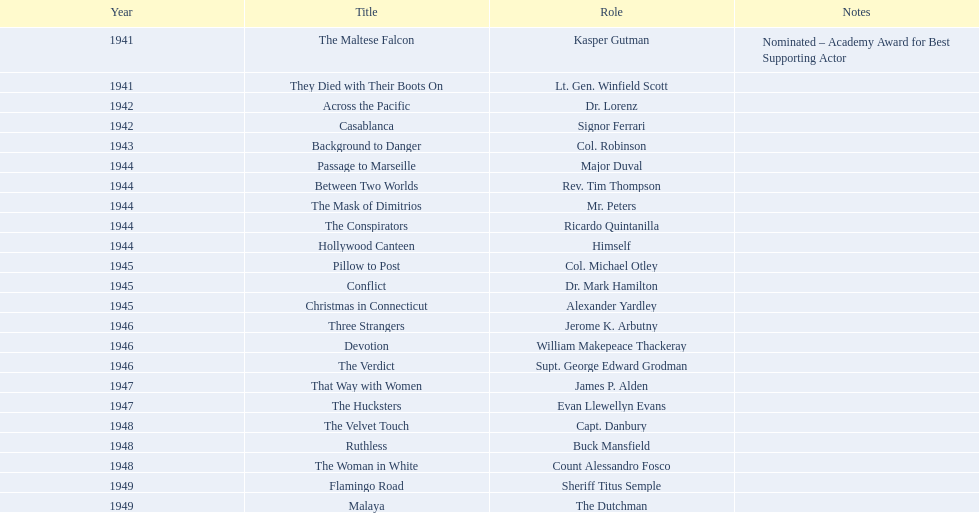What are the mentioned films? The Maltese Falcon, They Died with Their Boots On, Across the Pacific, Casablanca, Background to Danger, Passage to Marseille, Between Two Worlds, The Mask of Dimitrios, The Conspirators, Hollywood Canteen, Pillow to Post, Conflict, Christmas in Connecticut, Three Strangers, Devotion, The Verdict, That Way with Women, The Hucksters, The Velvet Touch, Ruthless, The Woman in White, Flamingo Road, Malaya. From those, in which ones did he earn an oscar nomination? The Maltese Falcon. 